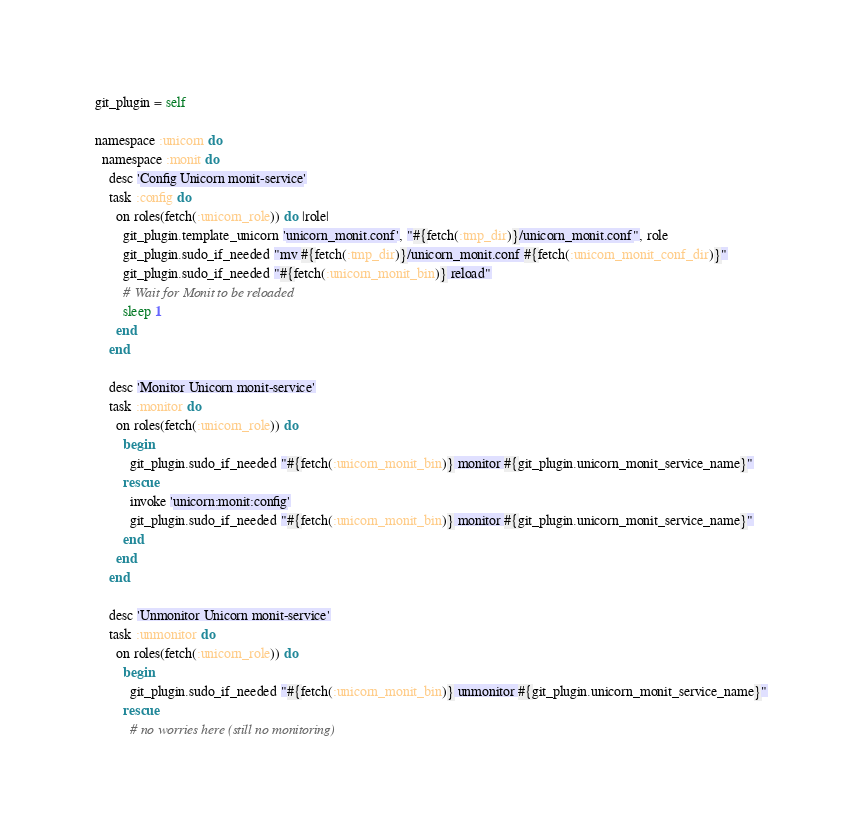<code> <loc_0><loc_0><loc_500><loc_500><_Ruby_>git_plugin = self

namespace :unicorn do
  namespace :monit do
    desc 'Config Unicorn monit-service'
    task :config do
      on roles(fetch(:unicorn_role)) do |role|
        git_plugin.template_unicorn 'unicorn_monit.conf', "#{fetch(:tmp_dir)}/unicorn_monit.conf", role
        git_plugin.sudo_if_needed "mv #{fetch(:tmp_dir)}/unicorn_monit.conf #{fetch(:unicorn_monit_conf_dir)}"
        git_plugin.sudo_if_needed "#{fetch(:unicorn_monit_bin)} reload"
        # Wait for Monit to be reloaded
        sleep 1
      end
    end

    desc 'Monitor Unicorn monit-service'
    task :monitor do
      on roles(fetch(:unicorn_role)) do
        begin
          git_plugin.sudo_if_needed "#{fetch(:unicorn_monit_bin)} monitor #{git_plugin.unicorn_monit_service_name}"
        rescue
          invoke 'unicorn:monit:config'
          git_plugin.sudo_if_needed "#{fetch(:unicorn_monit_bin)} monitor #{git_plugin.unicorn_monit_service_name}"
        end
      end
    end

    desc 'Unmonitor Unicorn monit-service'
    task :unmonitor do
      on roles(fetch(:unicorn_role)) do
        begin
          git_plugin.sudo_if_needed "#{fetch(:unicorn_monit_bin)} unmonitor #{git_plugin.unicorn_monit_service_name}"
        rescue
          # no worries here (still no monitoring)</code> 